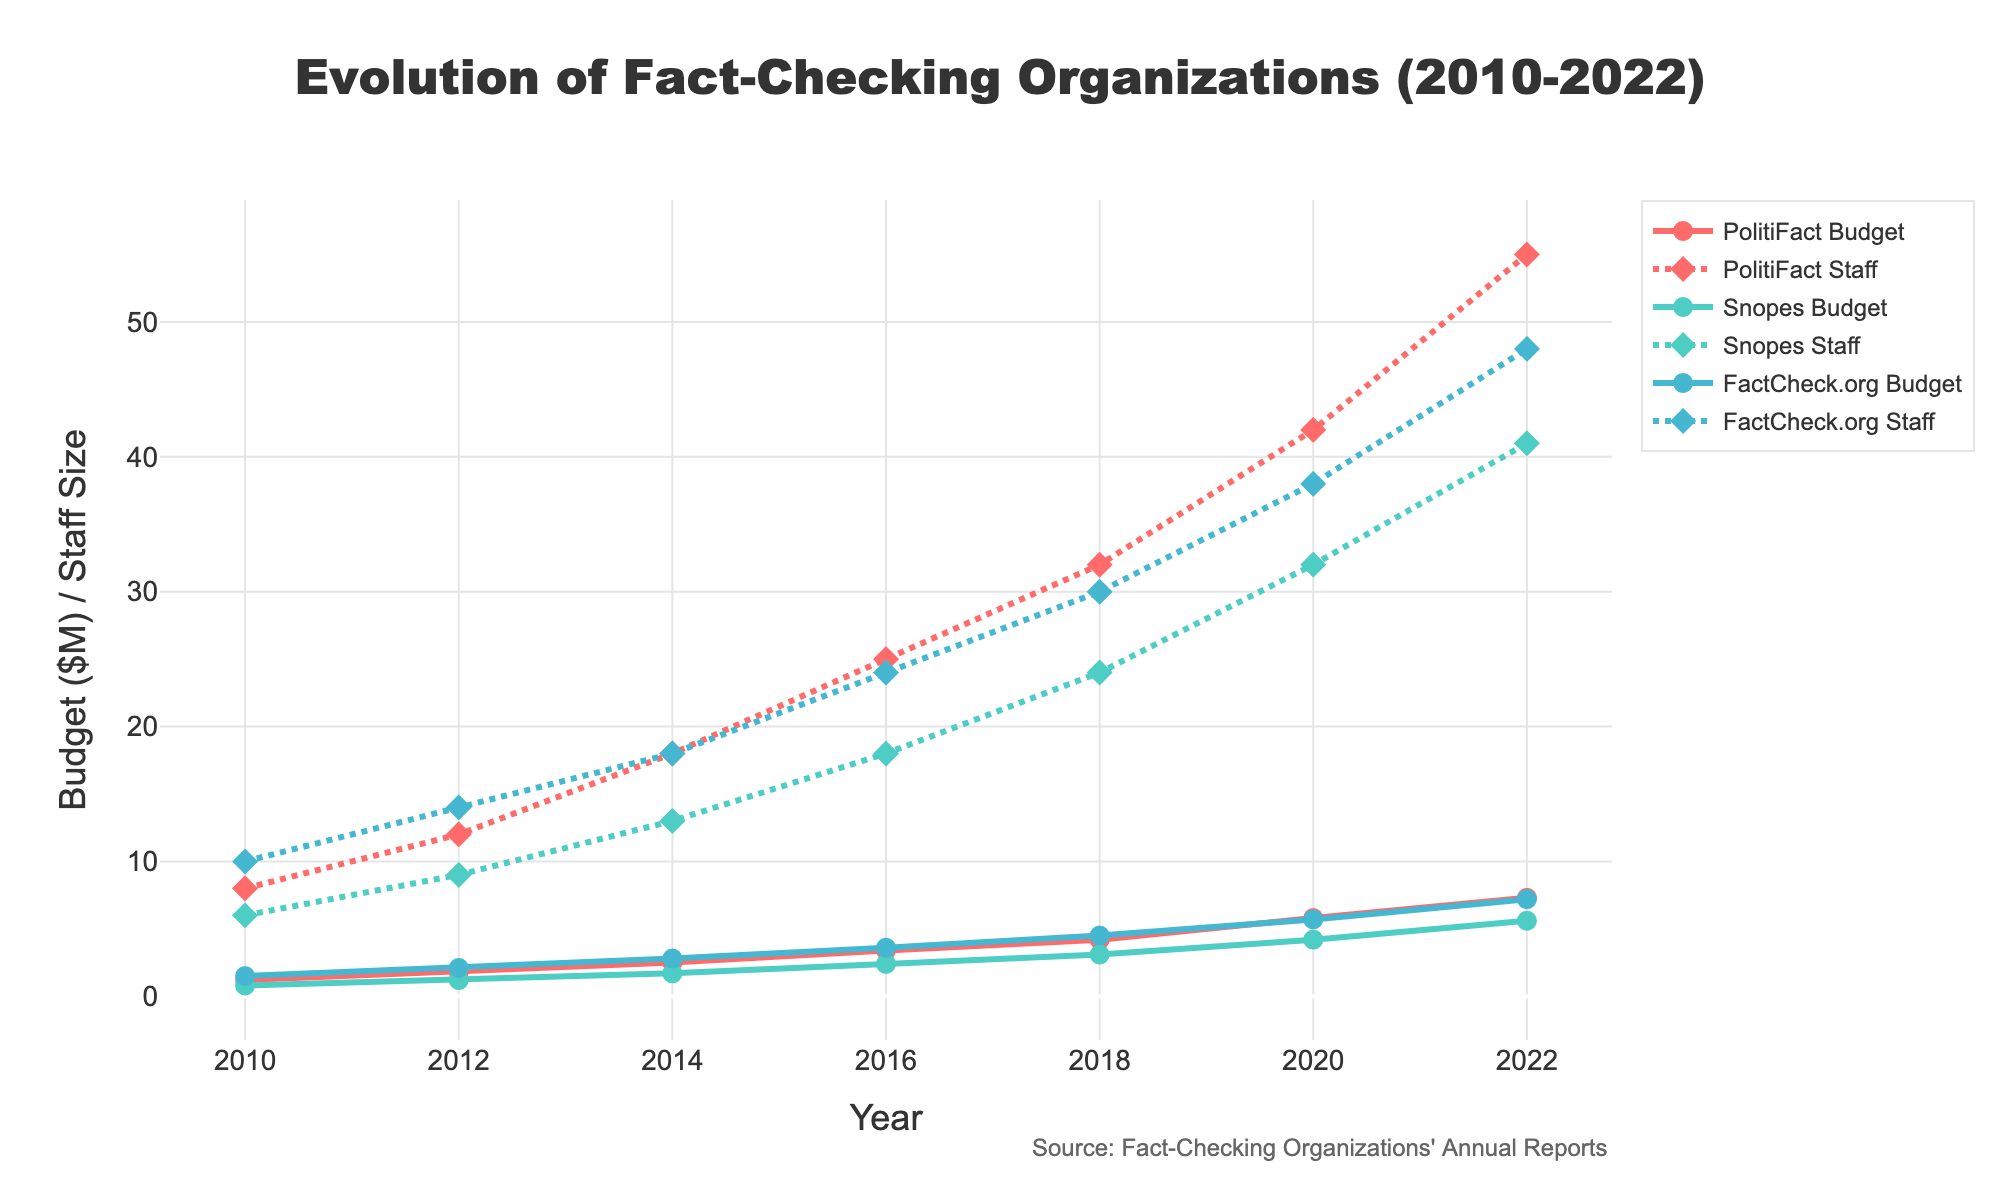What was the staff size for PolitiFact in 2020? To find the staff size for PolitiFact in 2020, look along the x-axis for the year 2020 and then trace vertically to the line marked for PolitiFact staff. The plot shows that the staff size is represented with diamond markers and matches the data point near 42 on the y-axis.
Answer: 42 Which organization had the highest budget in 2014 and what was it? Observe the data points for all organizations' budgets in 2014 by looking at where the year 2014 falls on the x-axis. The y-values of the line traces for PolitiFact, Snopes, and FactCheck.org must be compared. FactCheck.org has the highest y-value for the budget in this year, indicating about $2.8M.
Answer: FactCheck.org, $2.8M How much did Snopes' budget increase from 2010 to 2022? First, find Snopes' budgets in 2010 and 2022 on the y-axis and subtract the 2010 value from the 2022 value. In 2010, Snopes' budget was $0.8M, and in 2022, it was $5.6M. The increase is $5.6M - $0.8M = $4.8M.
Answer: $4.8M Compare the staff growth for PolitiFact and FactCheck.org from 2010 to 2022. Which one grew more and by how much? Check the staff sizes in 2010 and 2022 for both organizations on the y-axis and calculate the difference. PolitiFact had 8 staff in 2010 and 55 in 2022, resulting in an increase of 47. FactCheck.org had 10 staff in 2010 and 48 in 2022, resulting in an increase of 38. Therefore, PolitiFact grew more by 47 - 38 = 9 staff.
Answer: PolitiFact by 9 staff What is the average budget of FactCheck.org from 2010 to 2022? Add the annual budgets of FactCheck.org from 2010 to 2022 and divide by the number of years. The sum of the budgets is 1.5 + 2.1 + 2.8 + 3.6 + 4.5 + 5.7 + 7.2 = 27.4M. There are 7 data points from 2010 to 2022, so the average is 27.4 / 7 ≈ 3.91M.
Answer: $3.91M Between PolitiFact and Snopes, which had a larger budget increase from 2016 to 2020 and what is the difference in their increases? First, calculate the budget increases for both organizations. PolitiFact's budget increased from $3.4M in 2016 to $5.8M in 2020, which is $2.4M. Snopes' budget increased from $2.4M in 2016 to $4.2M in 2020, which is $1.8M. The difference in their increases is $2.4M - $1.8M = $0.6M.
Answer: PolitiFact, $0.6M Which organization had the slowest growth in staff from 2010 to 2022? Calculate the staff changes for each organization from 2010 to 2022. PolitiFact grew from 8 to 55 (increase of 47), Snopes grew from 6 to 41 (increase of 35), and FactCheck.org grew from 10 to 48 (increase of 38). Snopes had the slowest growth.
Answer: Snopes Did any organization's budget size exceed $6 million before 2020? Check all the budget traces before the year 2020 to see if the y-values (budgets) exceed $6 million. None of the organizations' budgets exceeded $6 million before 2020.
Answer: No 